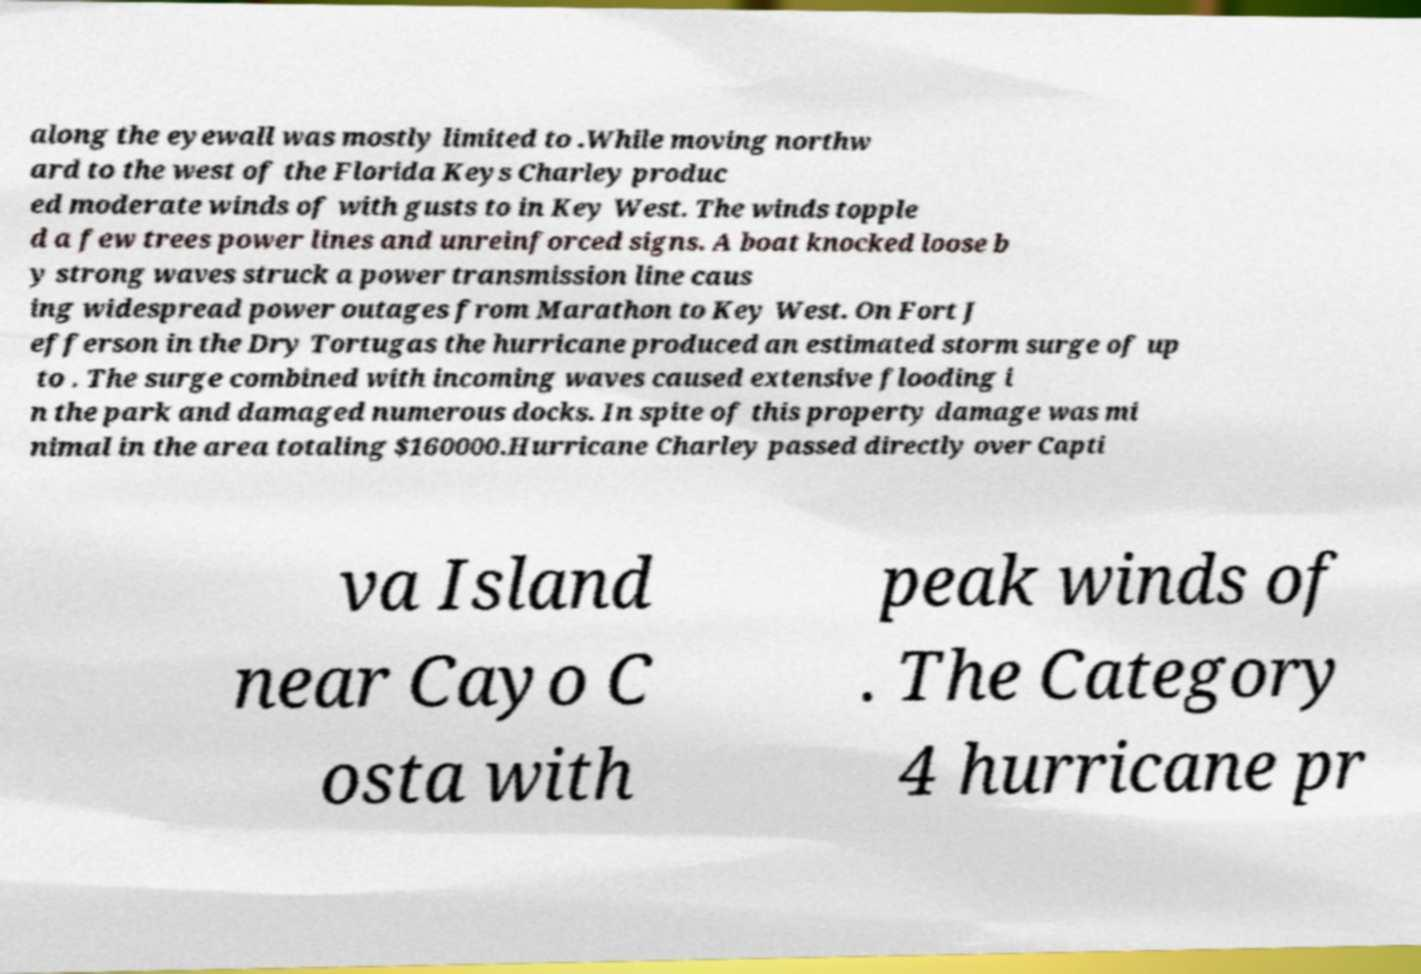Can you read and provide the text displayed in the image?This photo seems to have some interesting text. Can you extract and type it out for me? along the eyewall was mostly limited to .While moving northw ard to the west of the Florida Keys Charley produc ed moderate winds of with gusts to in Key West. The winds topple d a few trees power lines and unreinforced signs. A boat knocked loose b y strong waves struck a power transmission line caus ing widespread power outages from Marathon to Key West. On Fort J efferson in the Dry Tortugas the hurricane produced an estimated storm surge of up to . The surge combined with incoming waves caused extensive flooding i n the park and damaged numerous docks. In spite of this property damage was mi nimal in the area totaling $160000.Hurricane Charley passed directly over Capti va Island near Cayo C osta with peak winds of . The Category 4 hurricane pr 